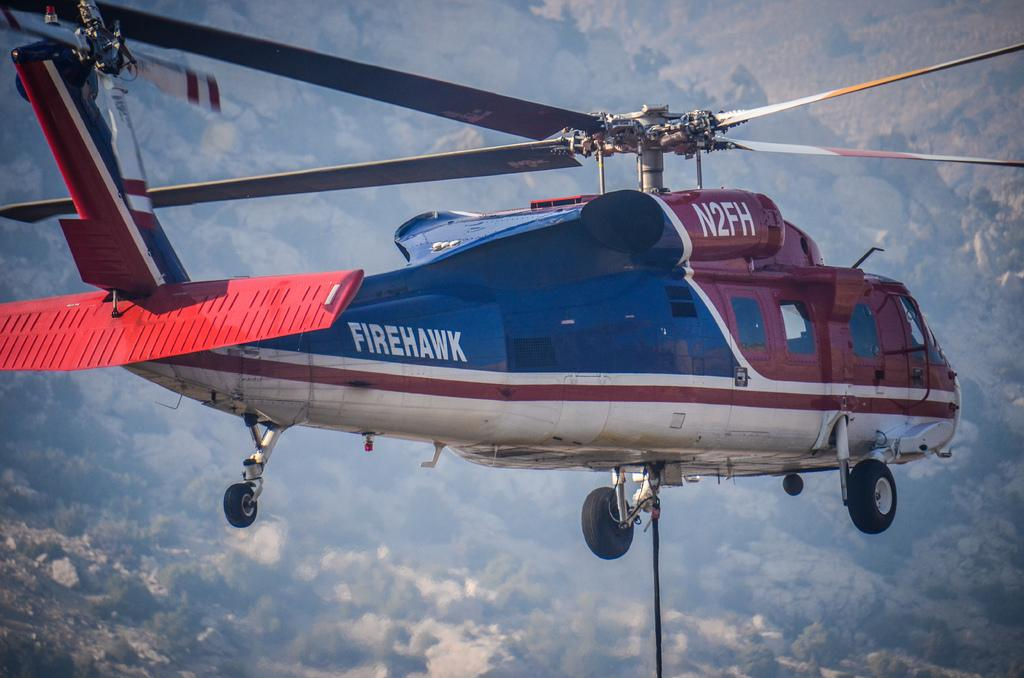Provide a one-sentence caption for the provided image. The red and blue helicopters name is Firehawk. 